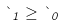Convert formula to latex. <formula><loc_0><loc_0><loc_500><loc_500>\theta _ { 1 } \geq \theta _ { 0 }</formula> 